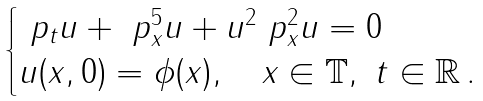Convert formula to latex. <formula><loc_0><loc_0><loc_500><loc_500>\begin{cases} \ p _ { t } u + \ p _ { x } ^ { 5 } u + u ^ { 2 } \ p ^ { 2 } _ { x } u = 0 \\ u ( x , 0 ) = \phi ( x ) , \quad x \in \mathbb { T } , \ t \in \mathbb { R } \, . \end{cases}</formula> 